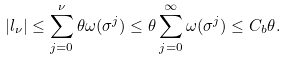Convert formula to latex. <formula><loc_0><loc_0><loc_500><loc_500>| l _ { \nu } | \leq \sum ^ { \nu } _ { j = 0 } \theta \omega ( \sigma ^ { j } ) \leq \theta \sum ^ { \infty } _ { j = 0 } \omega ( \sigma ^ { j } ) \leq C _ { b } \theta .</formula> 